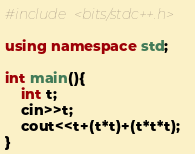<code> <loc_0><loc_0><loc_500><loc_500><_C++_>#include <bits/stdc++.h> 

using namespace std;

int main(){
	int t;
	cin>>t;
	cout<<t+(t*t)+(t*t*t);
}

</code> 